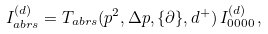<formula> <loc_0><loc_0><loc_500><loc_500>I _ { a b r s } ^ { ( d ) } = T _ { a b r s } ( p ^ { 2 } , \Delta p , \{ \partial \} , { d ^ { + } } ) \, I _ { 0 0 0 0 } ^ { ( d ) } \, ,</formula> 